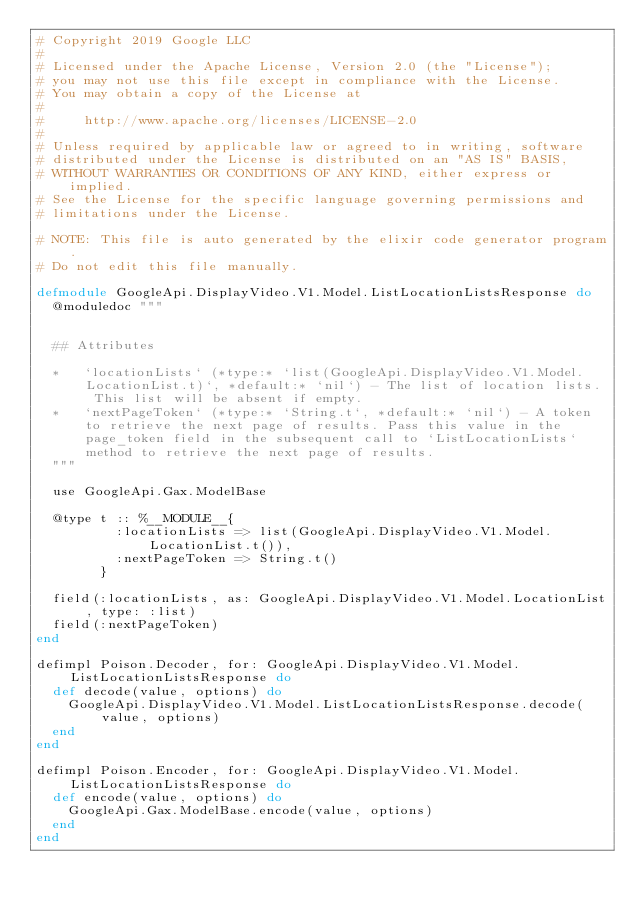Convert code to text. <code><loc_0><loc_0><loc_500><loc_500><_Elixir_># Copyright 2019 Google LLC
#
# Licensed under the Apache License, Version 2.0 (the "License");
# you may not use this file except in compliance with the License.
# You may obtain a copy of the License at
#
#     http://www.apache.org/licenses/LICENSE-2.0
#
# Unless required by applicable law or agreed to in writing, software
# distributed under the License is distributed on an "AS IS" BASIS,
# WITHOUT WARRANTIES OR CONDITIONS OF ANY KIND, either express or implied.
# See the License for the specific language governing permissions and
# limitations under the License.

# NOTE: This file is auto generated by the elixir code generator program.
# Do not edit this file manually.

defmodule GoogleApi.DisplayVideo.V1.Model.ListLocationListsResponse do
  @moduledoc """


  ## Attributes

  *   `locationLists` (*type:* `list(GoogleApi.DisplayVideo.V1.Model.LocationList.t)`, *default:* `nil`) - The list of location lists. This list will be absent if empty.
  *   `nextPageToken` (*type:* `String.t`, *default:* `nil`) - A token to retrieve the next page of results. Pass this value in the page_token field in the subsequent call to `ListLocationLists` method to retrieve the next page of results.
  """

  use GoogleApi.Gax.ModelBase

  @type t :: %__MODULE__{
          :locationLists => list(GoogleApi.DisplayVideo.V1.Model.LocationList.t()),
          :nextPageToken => String.t()
        }

  field(:locationLists, as: GoogleApi.DisplayVideo.V1.Model.LocationList, type: :list)
  field(:nextPageToken)
end

defimpl Poison.Decoder, for: GoogleApi.DisplayVideo.V1.Model.ListLocationListsResponse do
  def decode(value, options) do
    GoogleApi.DisplayVideo.V1.Model.ListLocationListsResponse.decode(value, options)
  end
end

defimpl Poison.Encoder, for: GoogleApi.DisplayVideo.V1.Model.ListLocationListsResponse do
  def encode(value, options) do
    GoogleApi.Gax.ModelBase.encode(value, options)
  end
end
</code> 